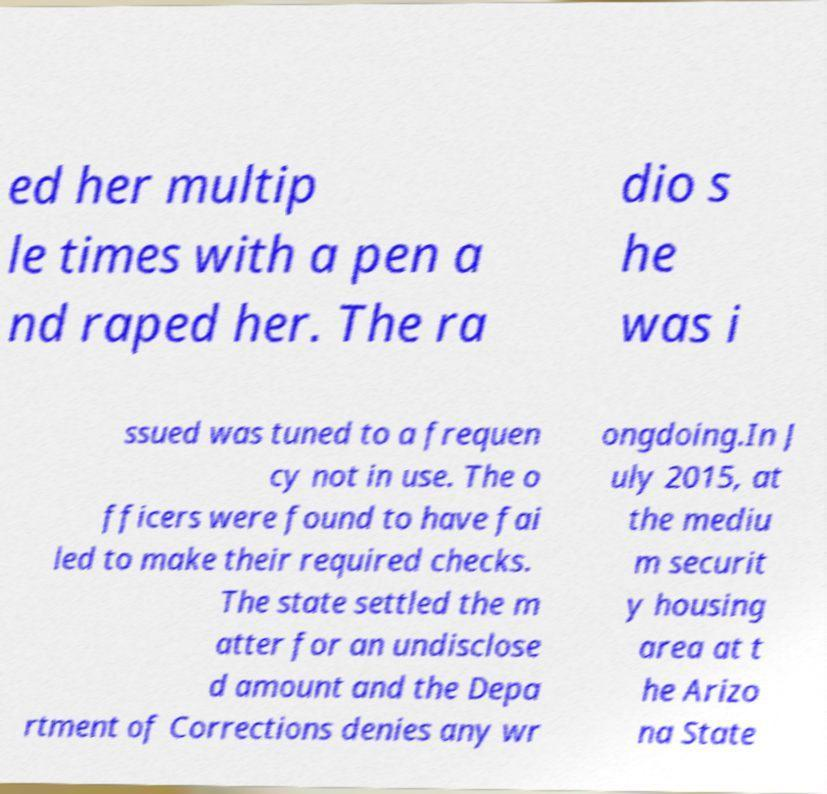What messages or text are displayed in this image? I need them in a readable, typed format. ed her multip le times with a pen a nd raped her. The ra dio s he was i ssued was tuned to a frequen cy not in use. The o fficers were found to have fai led to make their required checks. The state settled the m atter for an undisclose d amount and the Depa rtment of Corrections denies any wr ongdoing.In J uly 2015, at the mediu m securit y housing area at t he Arizo na State 